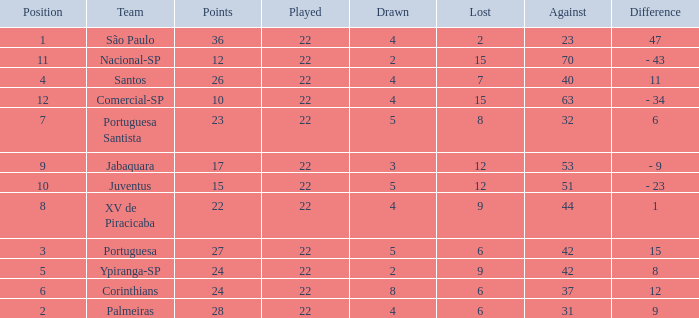Which Played has a Lost larger than 9, and a Points smaller than 15, and a Position smaller than 12, and a Drawn smaller than 2? None. 